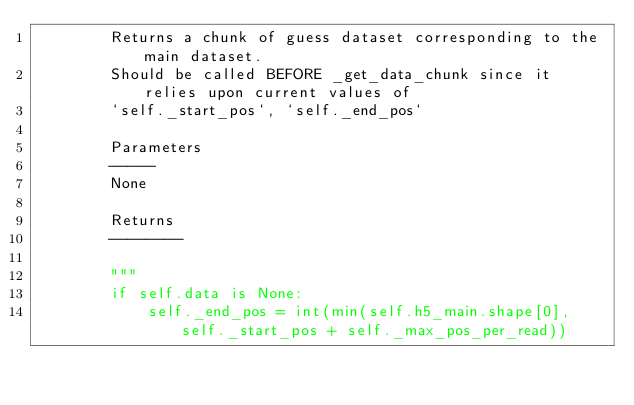Convert code to text. <code><loc_0><loc_0><loc_500><loc_500><_Python_>        Returns a chunk of guess dataset corresponding to the main dataset.
        Should be called BEFORE _get_data_chunk since it relies upon current values of
        `self._start_pos`, `self._end_pos`

        Parameters
        -----
        None

        Returns
        --------

        """
        if self.data is None:
            self._end_pos = int(min(self.h5_main.shape[0], self._start_pos + self._max_pos_per_read))</code> 